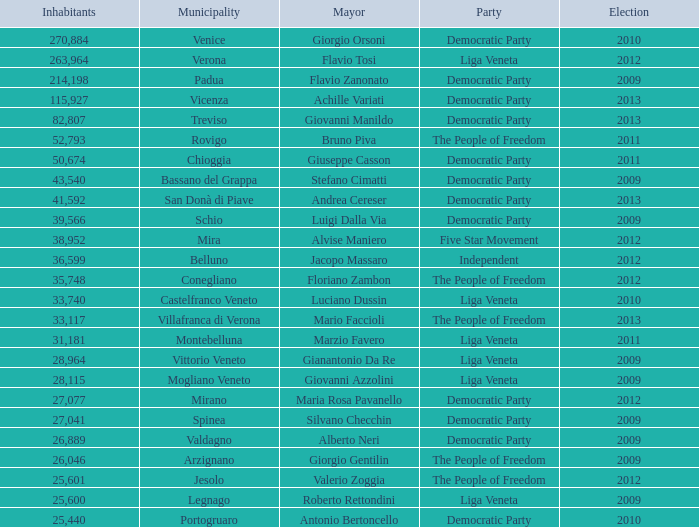How many Inhabitants were in the democratic party for an election before 2009 for Mayor of stefano cimatti? 0.0. 